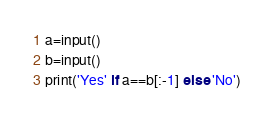Convert code to text. <code><loc_0><loc_0><loc_500><loc_500><_Python_>a=input()
b=input()
print('Yes' if a==b[:-1] else 'No')</code> 